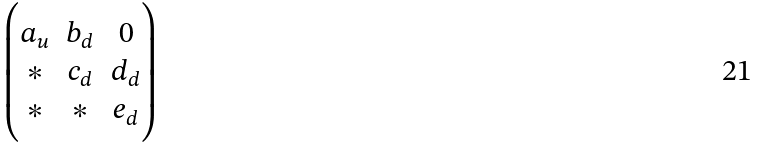<formula> <loc_0><loc_0><loc_500><loc_500>\begin{pmatrix} a _ { u } & b _ { d } & 0 \\ * & c _ { d } & d _ { d } \\ * & * & e _ { d } \end{pmatrix}</formula> 